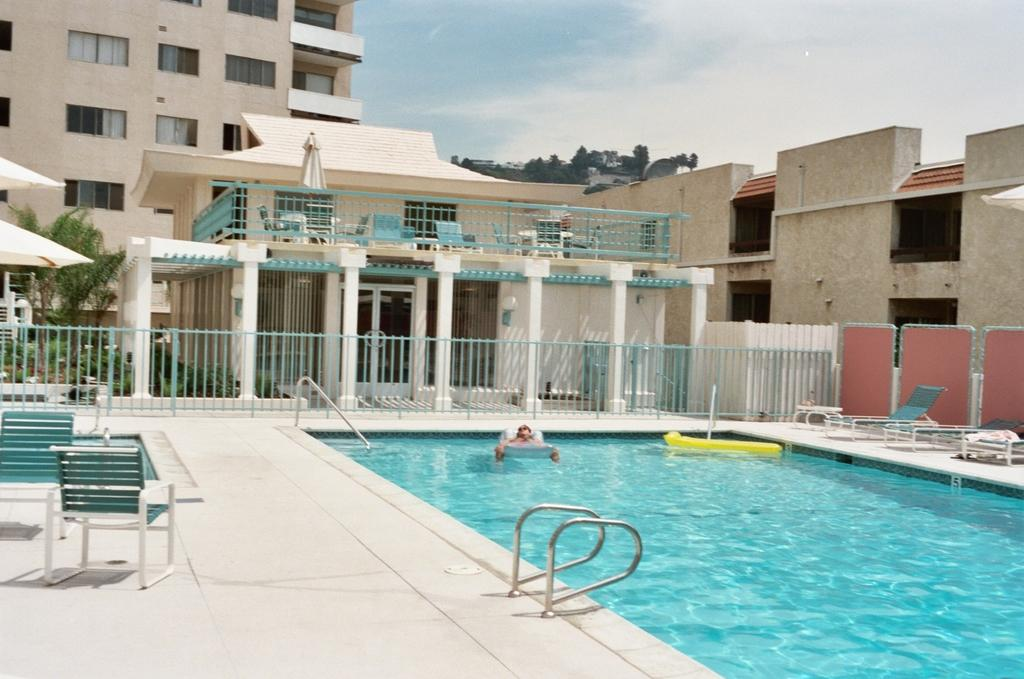What type of structure can be seen in the background of the image? There is a building in the background of the image. What can be seen in the sky in the image? The sky is visible in the background of the image. What type of vegetation is present in the background of the image? There are trees in the background of the image. What is located at the bottom of the image? There is a swimming pool at the bottom of the image. What type of furniture is present in the image? There are chairs in the image. What type of barrier is present in the image? There is a metal railing in the image. What type of cap is floating on the liquid in the image? There is no cap or liquid present in the image. How many glasses are visible in the image? There are no glasses visible in the image. 